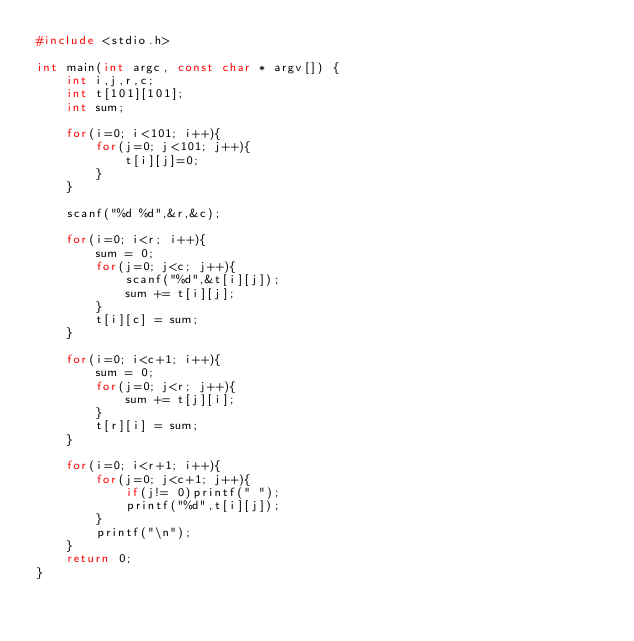<code> <loc_0><loc_0><loc_500><loc_500><_C_>#include <stdio.h>

int main(int argc, const char * argv[]) {
    int i,j,r,c;
    int t[101][101];
    int sum;
    
    for(i=0; i<101; i++){
        for(j=0; j<101; j++){
            t[i][j]=0;
        }
    }
    
    scanf("%d %d",&r,&c);
    
    for(i=0; i<r; i++){
        sum = 0;
        for(j=0; j<c; j++){
            scanf("%d",&t[i][j]);
            sum += t[i][j];
        }
        t[i][c] = sum;
    }
    
    for(i=0; i<c+1; i++){
        sum = 0;
        for(j=0; j<r; j++){
            sum += t[j][i];
        }
        t[r][i] = sum;
    }
    
    for(i=0; i<r+1; i++){
        for(j=0; j<c+1; j++){
            if(j!= 0)printf(" ");
            printf("%d",t[i][j]);
        }
        printf("\n");
    }
    return 0;
}

</code> 